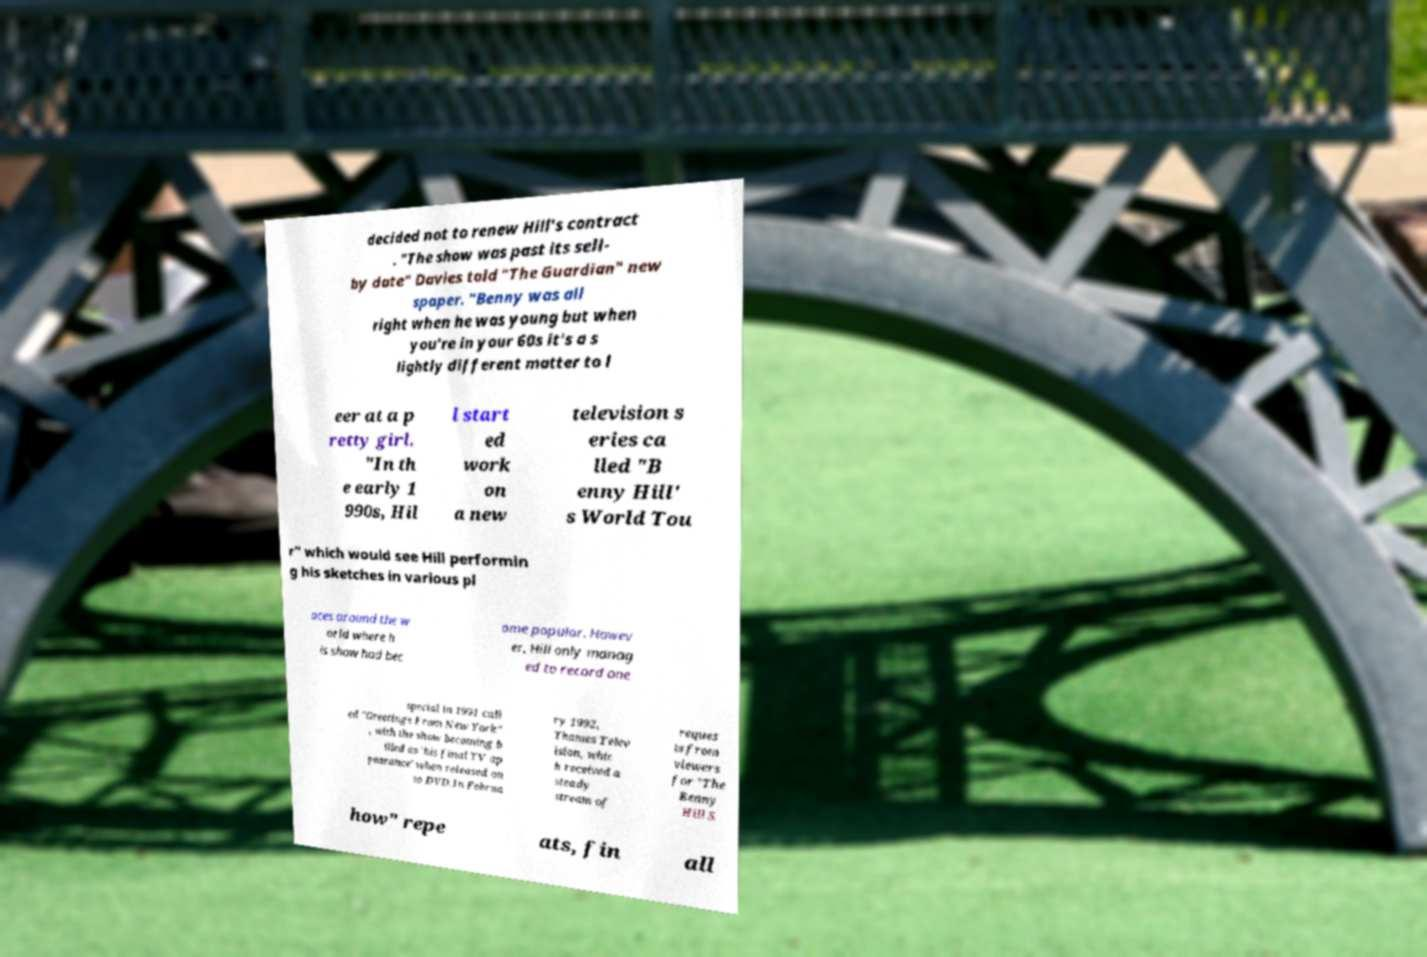For documentation purposes, I need the text within this image transcribed. Could you provide that? decided not to renew Hill's contract . "The show was past its sell- by date" Davies told "The Guardian" new spaper. "Benny was all right when he was young but when you're in your 60s it's a s lightly different matter to l eer at a p retty girl. "In th e early 1 990s, Hil l start ed work on a new television s eries ca lled "B enny Hill' s World Tou r" which would see Hill performin g his sketches in various pl aces around the w orld where h is show had bec ome popular. Howev er, Hill only manag ed to record one special in 1991 call ed "Greetings From New York" , with the show becoming b illed as 'his final TV ap pearance' when released on to DVD.In Februa ry 1992, Thames Telev ision, whic h received a steady stream of reques ts from viewers for "The Benny Hill S how" repe ats, fin all 